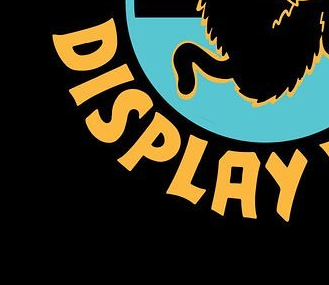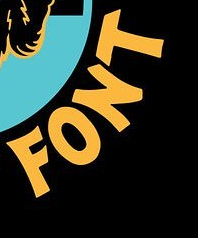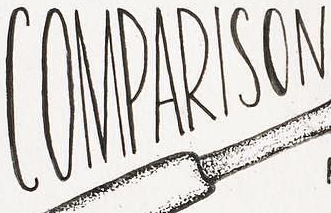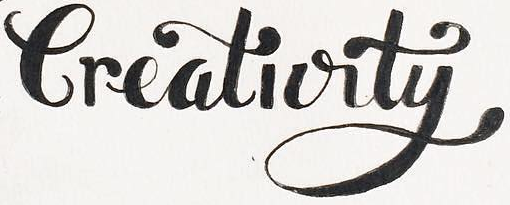What text is displayed in these images sequentially, separated by a semicolon? DISPLAY; FONT; COMPARISON; Creativity 